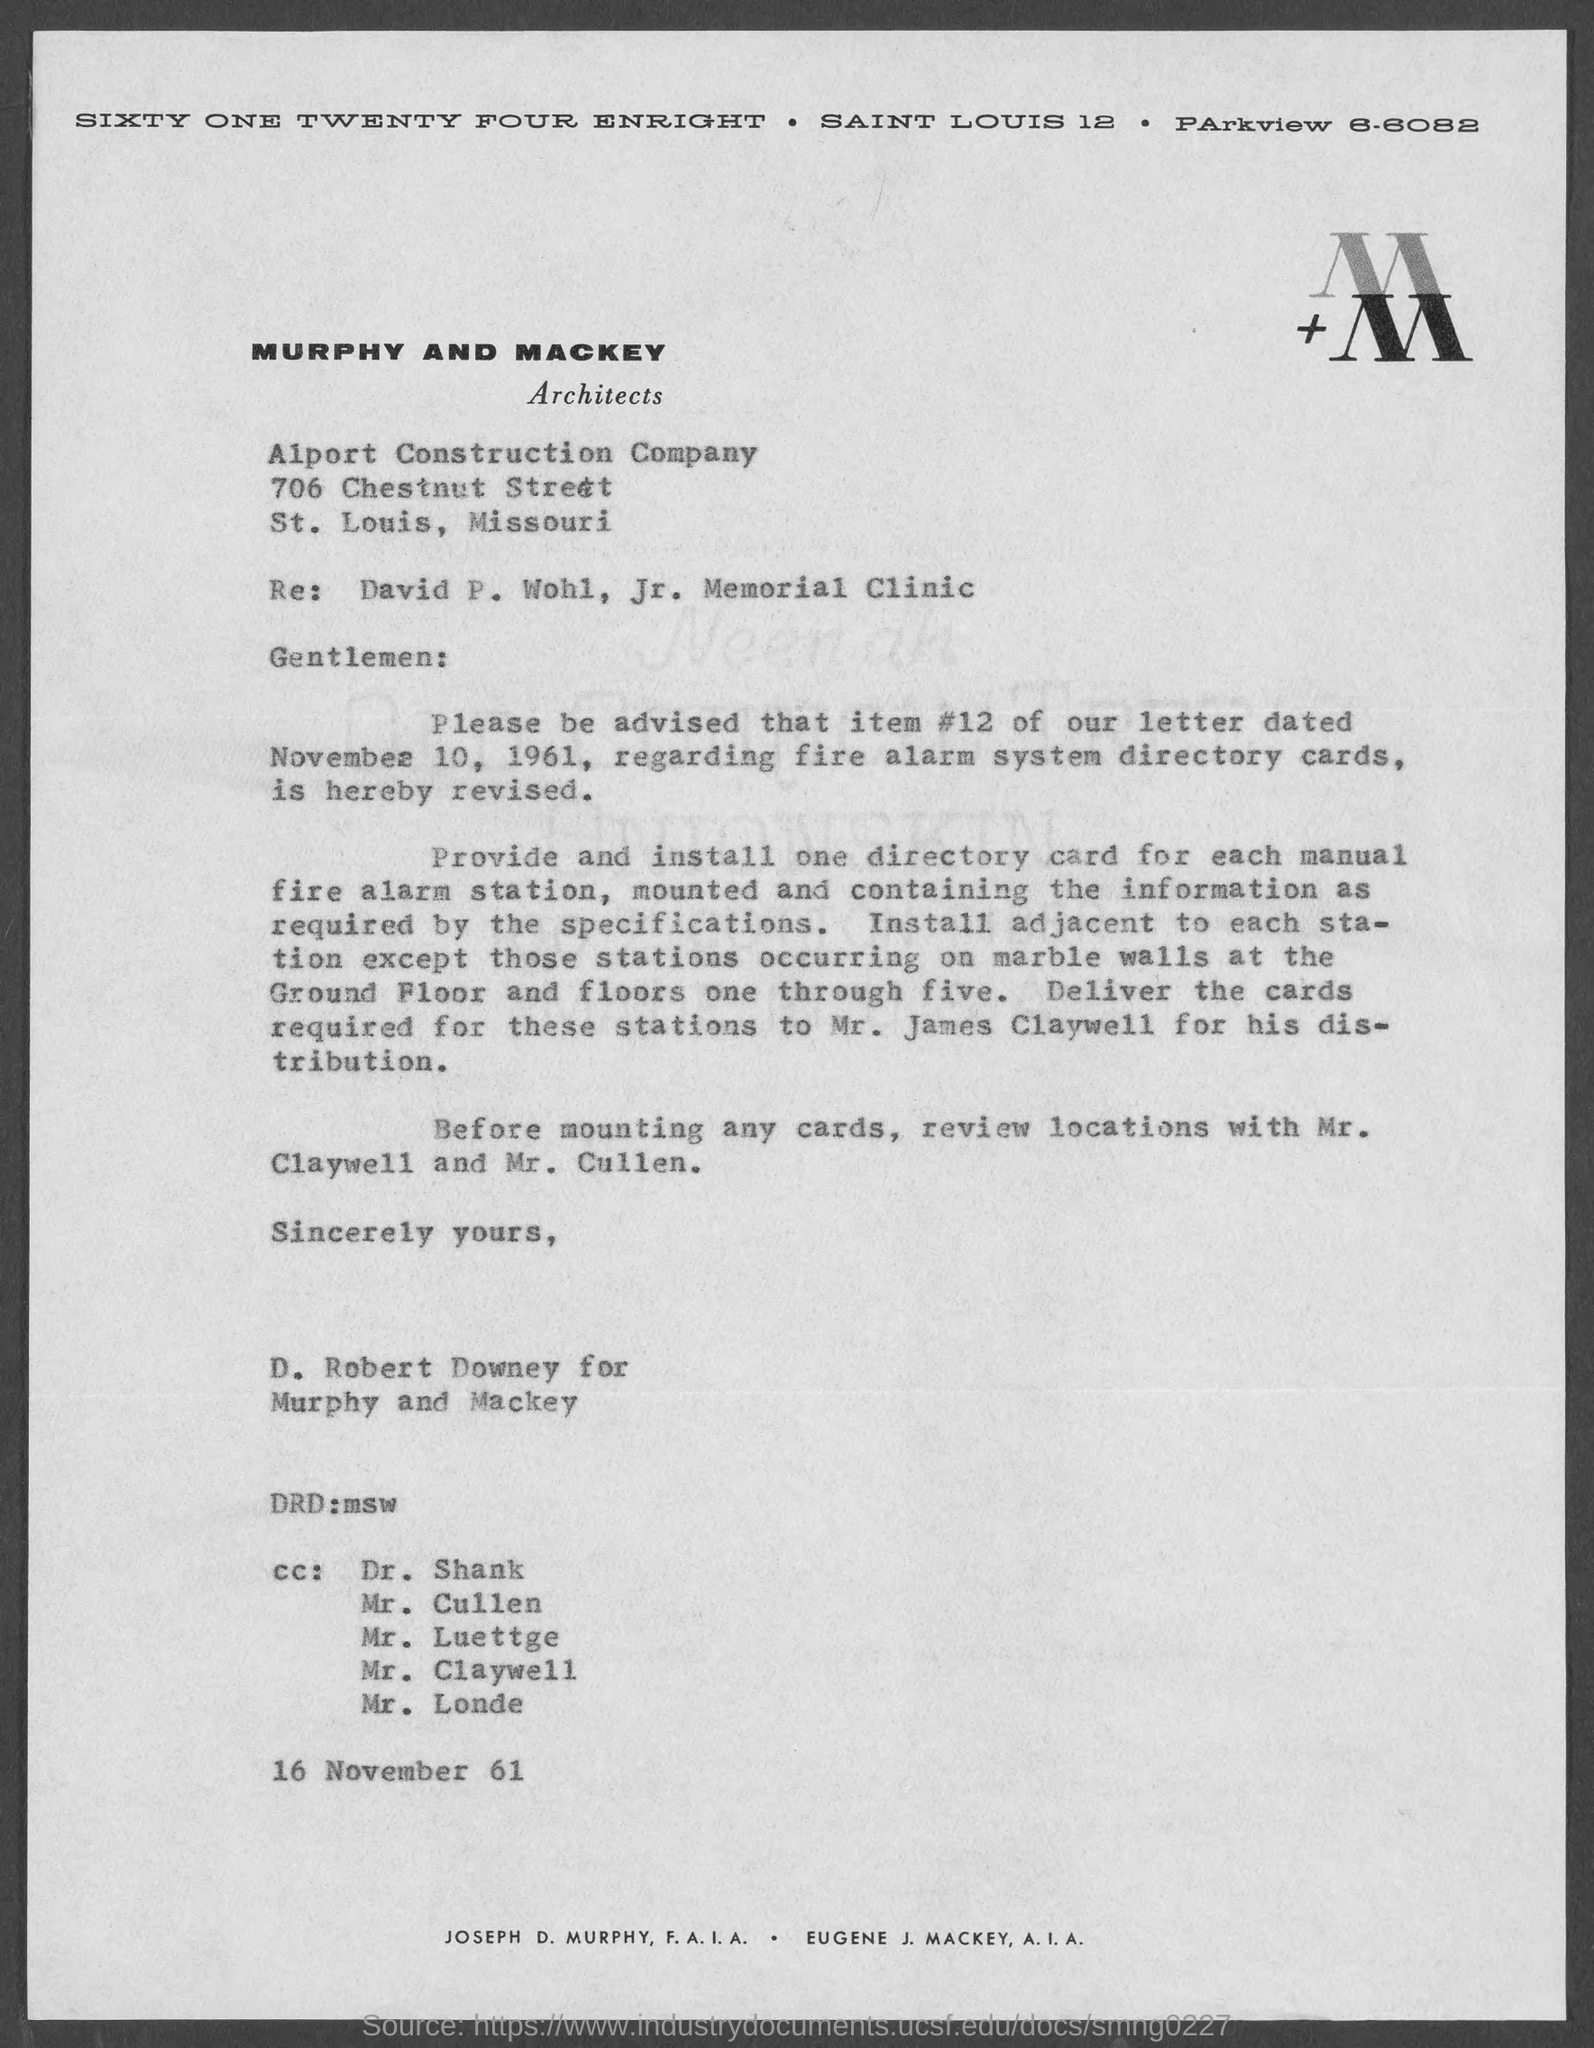Mention a couple of crucial points in this snapshot. To whom is the card required for distribution should be delivered to is Mr. James Claywell. Item #12, mentioned in the letter dated November 10, 1961, pertains to the fire alarm system directory cards. 